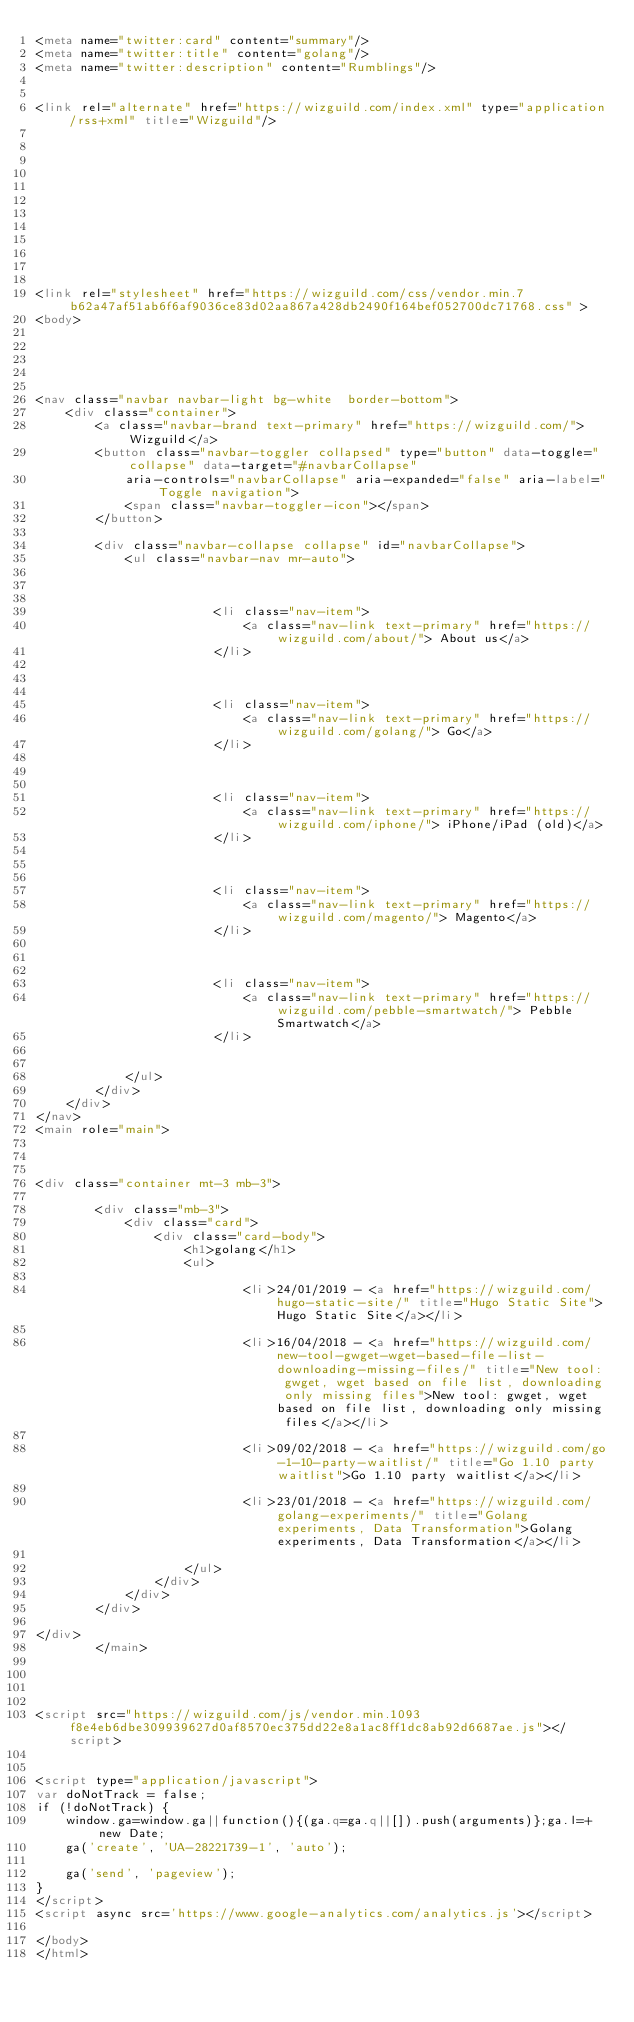Convert code to text. <code><loc_0><loc_0><loc_500><loc_500><_HTML_><meta name="twitter:card" content="summary"/>
<meta name="twitter:title" content="golang"/>
<meta name="twitter:description" content="Rumblings"/>


<link rel="alternate" href="https://wizguild.com/index.xml" type="application/rss+xml" title="Wizguild"/>



    








<link rel="stylesheet" href="https://wizguild.com/css/vendor.min.7b62a47af51ab6f6af9036ce83d02aa867a428db2490f164bef052700dc71768.css" >
<body>





<nav class="navbar navbar-light bg-white  border-bottom">
    <div class="container">
        <a class="navbar-brand text-primary" href="https://wizguild.com/">Wizguild</a>
        <button class="navbar-toggler collapsed" type="button" data-toggle="collapse" data-target="#navbarCollapse"
            aria-controls="navbarCollapse" aria-expanded="false" aria-label="Toggle navigation">
            <span class="navbar-toggler-icon"></span>
        </button>

        <div class="navbar-collapse collapse" id="navbarCollapse">
            <ul class="navbar-nav mr-auto">
                
                
                    
                        <li class="nav-item">
                            <a class="nav-link text-primary" href="https://wizguild.com/about/"> About us</a>
                        </li>
                    
                
                    
                        <li class="nav-item">
                            <a class="nav-link text-primary" href="https://wizguild.com/golang/"> Go</a>
                        </li>
                    
                
                    
                        <li class="nav-item">
                            <a class="nav-link text-primary" href="https://wizguild.com/iphone/"> iPhone/iPad (old)</a>
                        </li>
                    
                
                    
                        <li class="nav-item">
                            <a class="nav-link text-primary" href="https://wizguild.com/magento/"> Magento</a>
                        </li>
                    
                
                    
                        <li class="nav-item">
                            <a class="nav-link text-primary" href="https://wizguild.com/pebble-smartwatch/"> Pebble Smartwatch</a>
                        </li>
                    
                
            </ul>
        </div>
    </div>
</nav>
<main role="main">



<div class="container mt-3 mb-3">
    
        <div class="mb-3">    
            <div class="card">
                <div class="card-body">  
                    <h1>golang</h1>
                    <ul>
                        
                            <li>24/01/2019 - <a href="https://wizguild.com/hugo-static-site/" title="Hugo Static Site">Hugo Static Site</a></li>
                        
                            <li>16/04/2018 - <a href="https://wizguild.com/new-tool-gwget-wget-based-file-list-downloading-missing-files/" title="New tool: gwget, wget based on file list, downloading only missing files">New tool: gwget, wget based on file list, downloading only missing files</a></li>
                        
                            <li>09/02/2018 - <a href="https://wizguild.com/go-1-10-party-waitlist/" title="Go 1.10 party waitlist">Go 1.10 party waitlist</a></li>
                        
                            <li>23/01/2018 - <a href="https://wizguild.com/golang-experiments/" title="Golang experiments, Data Transformation">Golang experiments, Data Transformation</a></li>
                        
                    </ul>
                </div>
            </div>
        </div>
    
</div>
        </main>




<script src="https://wizguild.com/js/vendor.min.1093f8e4eb6dbe309939627d0af8570ec375dd22e8a1ac8ff1dc8ab92d6687ae.js"></script>


<script type="application/javascript">
var doNotTrack = false;
if (!doNotTrack) {
	window.ga=window.ga||function(){(ga.q=ga.q||[]).push(arguments)};ga.l=+new Date;
	ga('create', 'UA-28221739-1', 'auto');
	
	ga('send', 'pageview');
}
</script>
<script async src='https://www.google-analytics.com/analytics.js'></script>

</body>
</html>
</code> 